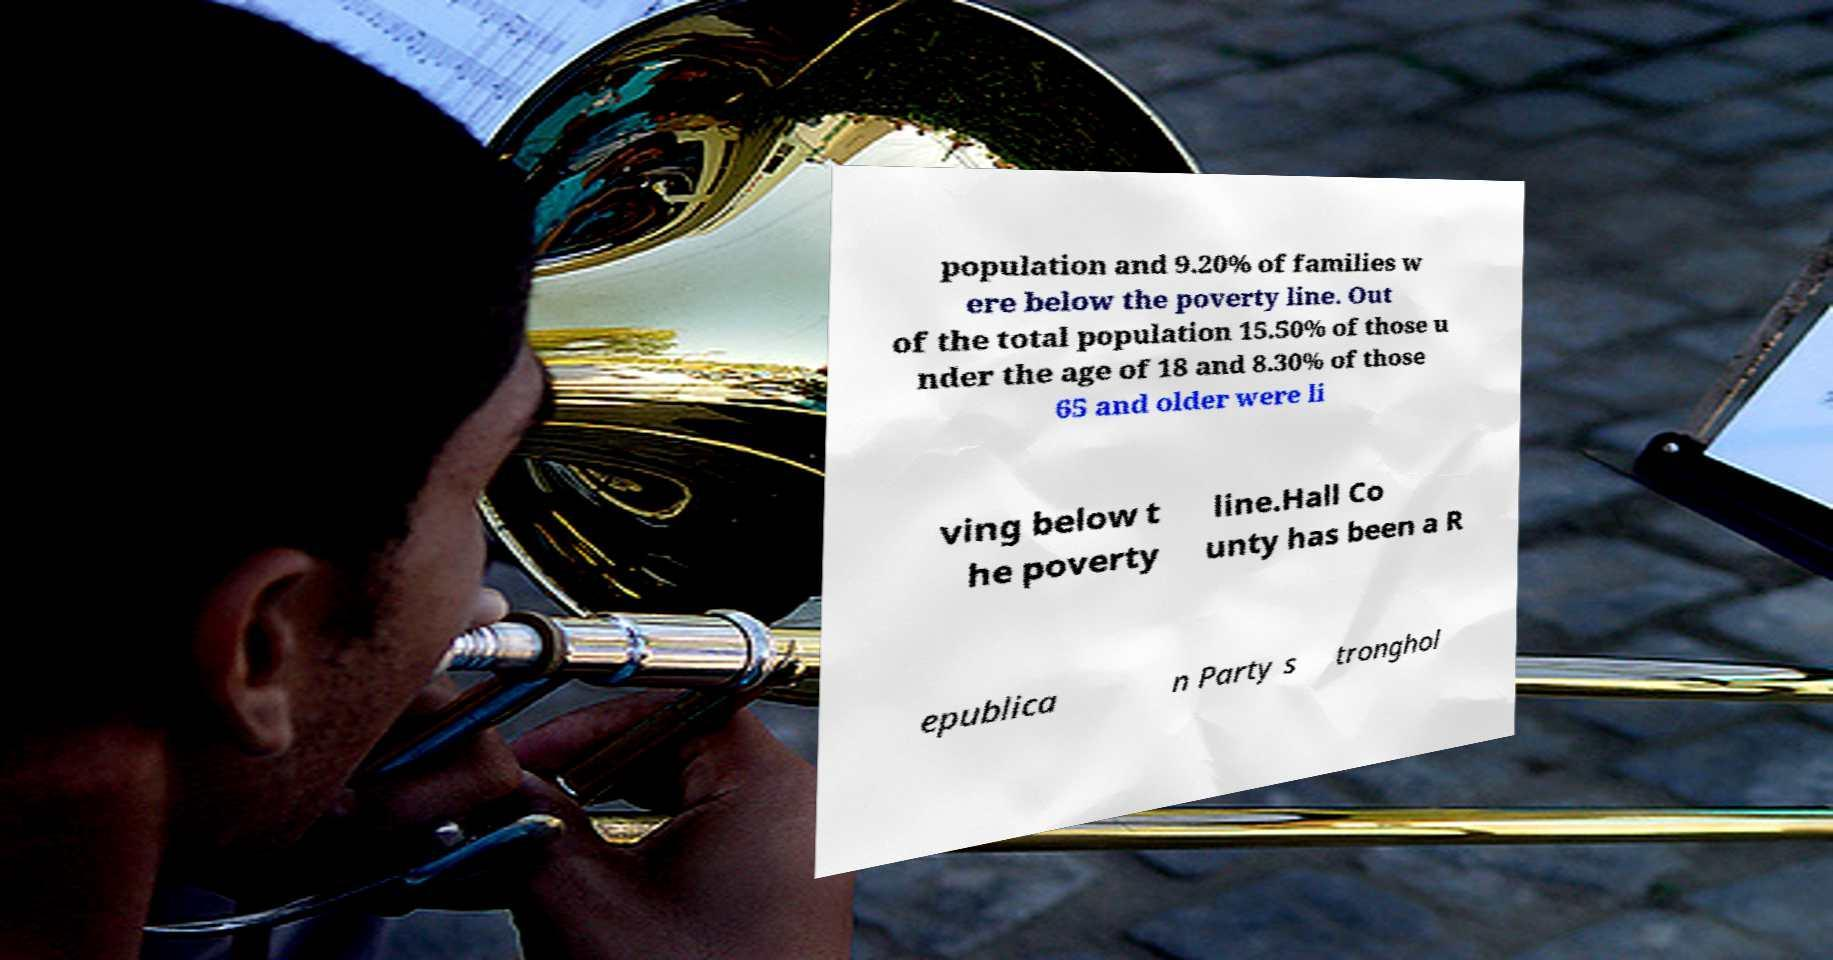Can you read and provide the text displayed in the image?This photo seems to have some interesting text. Can you extract and type it out for me? population and 9.20% of families w ere below the poverty line. Out of the total population 15.50% of those u nder the age of 18 and 8.30% of those 65 and older were li ving below t he poverty line.Hall Co unty has been a R epublica n Party s tronghol 